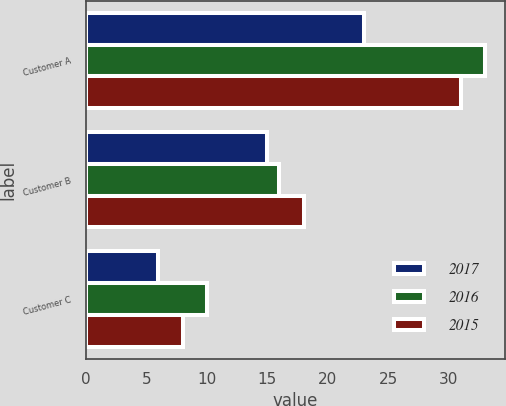Convert chart. <chart><loc_0><loc_0><loc_500><loc_500><stacked_bar_chart><ecel><fcel>Customer A<fcel>Customer B<fcel>Customer C<nl><fcel>2017<fcel>23<fcel>15<fcel>6<nl><fcel>2016<fcel>33<fcel>16<fcel>10<nl><fcel>2015<fcel>31<fcel>18<fcel>8<nl></chart> 